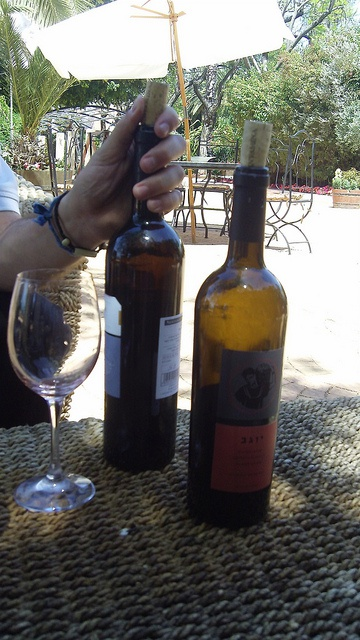Describe the objects in this image and their specific colors. I can see dining table in lightgreen, black, and gray tones, bottle in lightgreen, black, olive, and gray tones, bottle in lightgreen, black, gray, and darkblue tones, people in lightgreen, gray, black, and lightgray tones, and umbrella in lightgreen, white, tan, gray, and darkgray tones in this image. 